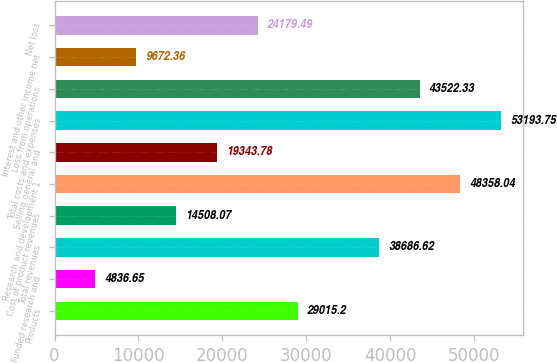Convert chart to OTSL. <chart><loc_0><loc_0><loc_500><loc_500><bar_chart><fcel>Products<fcel>Funded research and<fcel>Total revenues<fcel>Cost of product revenues<fcel>Research and development 1<fcel>Selling general and<fcel>Total costs and expenses<fcel>Loss from operations<fcel>Interest and other income net<fcel>Net loss<nl><fcel>29015.2<fcel>4836.65<fcel>38686.6<fcel>14508.1<fcel>48358<fcel>19343.8<fcel>53193.8<fcel>43522.3<fcel>9672.36<fcel>24179.5<nl></chart> 